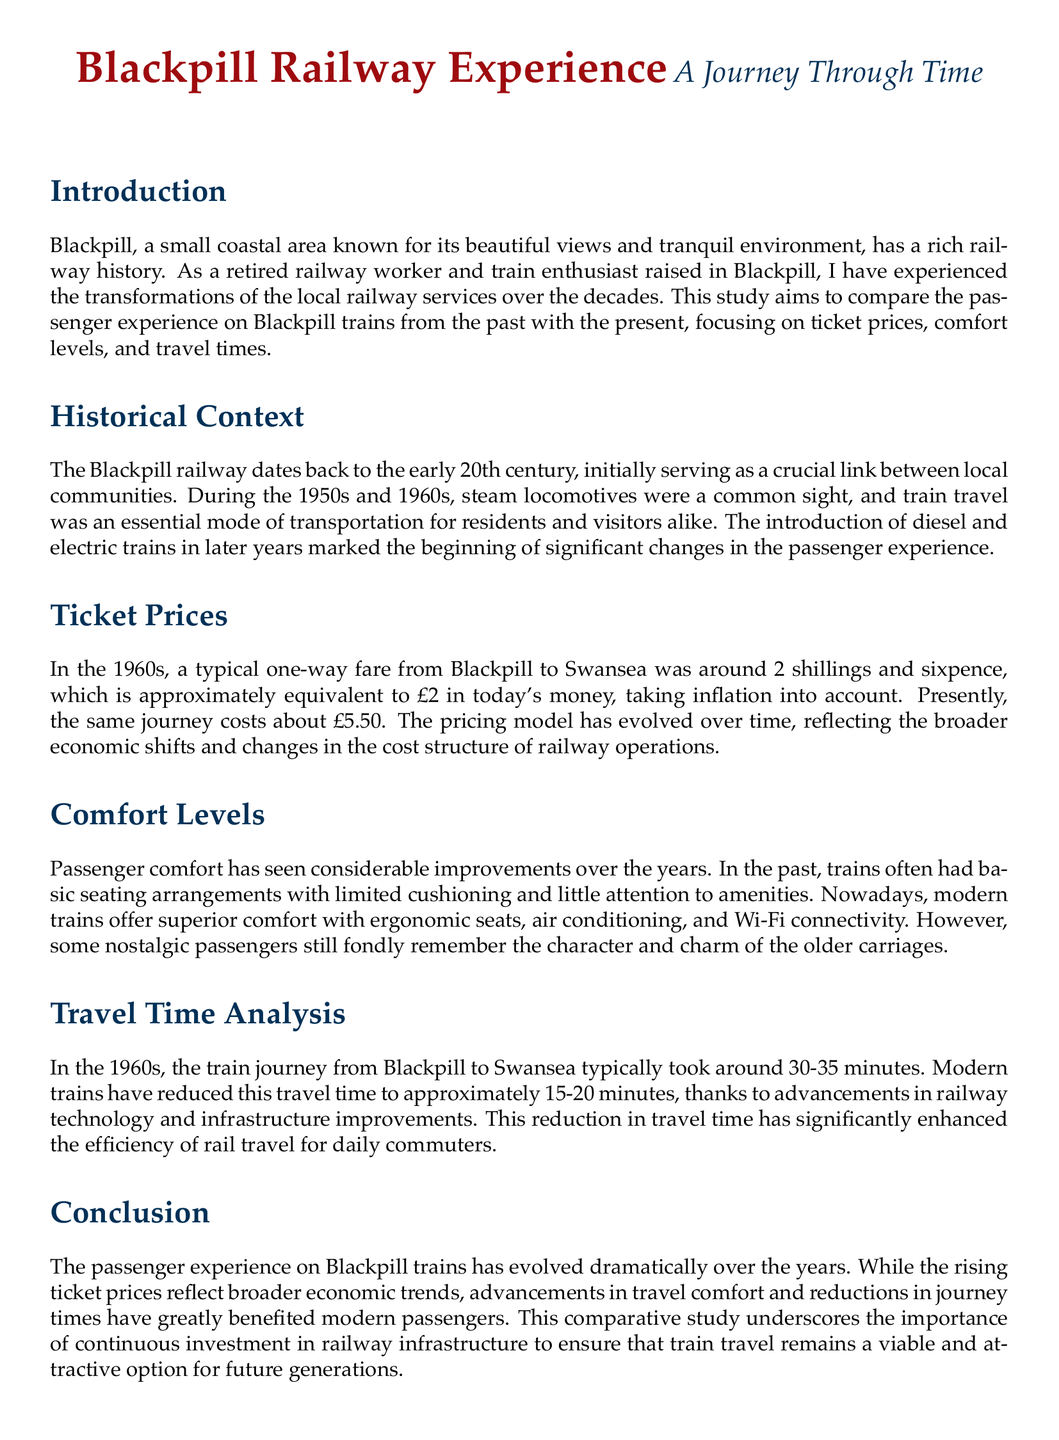What was a typical one-way fare from Blackpill to Swansea in the 1960s? The document states that a typical one-way fare was around 2 shillings and sixpence, which is approximately equivalent to £2 in today's money.
Answer: £2 What is the current ticket price for the same journey? The document notes that the present cost for a one-way ticket from Blackpill to Swansea is about £5.50.
Answer: £5.50 How long did the train journey take from Blackpill to Swansea in the 1960s? According to the document, the journey typically took around 30-35 minutes.
Answer: 30-35 minutes What is the current travel time for the same journey? The modern trains have reduced the travel time to approximately 15-20 minutes.
Answer: 15-20 minutes What major improvements are noted in the comfort levels of trains today? The document mentions ergonomic seats, air conditioning, and Wi-Fi connectivity as significant improvements in passenger comfort.
Answer: Ergonomic seats, air conditioning, and Wi-Fi How has the evolution of ticket prices reflected broader economic shifts? The document indicates that the pricing model has evolved over time which reflects changes in the cost structure of railway operations.
Answer: Economic shifts What railway technology advancement has helped reduce travel times? The document attributes the reduction in travel time to advancements in railway technology and infrastructure improvements.
Answer: Railway technology advancements What is the importance of continuous investment in railway infrastructure? According to the conclusion of the document, it ensures that train travel remains a viable and attractive option for future generations.
Answer: Viable and attractive train travel 